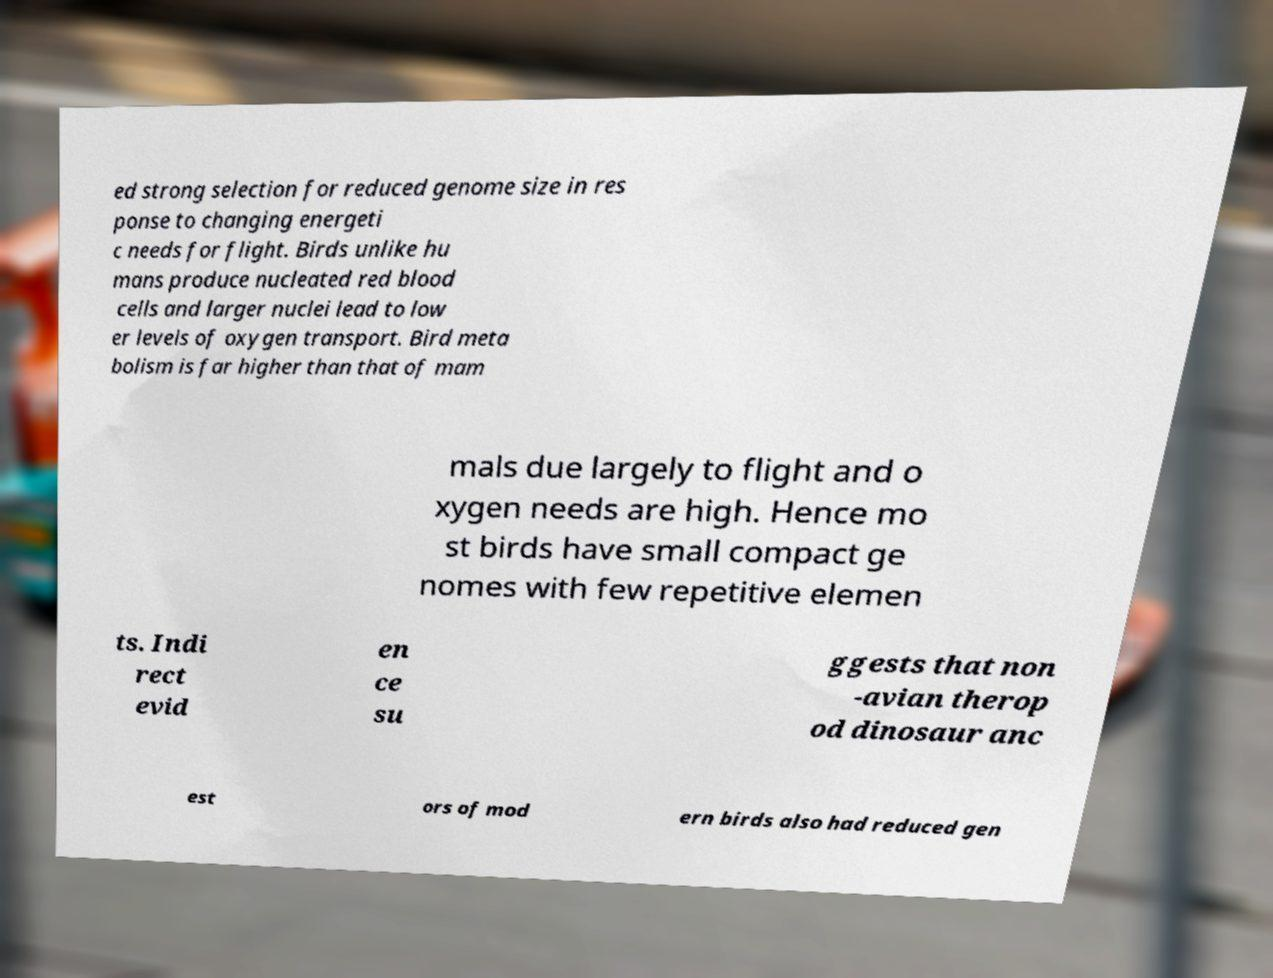For documentation purposes, I need the text within this image transcribed. Could you provide that? ed strong selection for reduced genome size in res ponse to changing energeti c needs for flight. Birds unlike hu mans produce nucleated red blood cells and larger nuclei lead to low er levels of oxygen transport. Bird meta bolism is far higher than that of mam mals due largely to flight and o xygen needs are high. Hence mo st birds have small compact ge nomes with few repetitive elemen ts. Indi rect evid en ce su ggests that non -avian therop od dinosaur anc est ors of mod ern birds also had reduced gen 